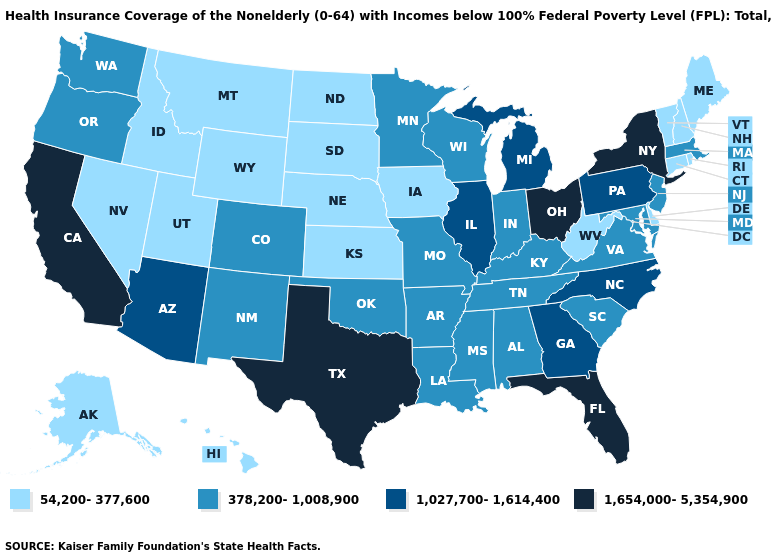Does the map have missing data?
Be succinct. No. What is the highest value in states that border Kentucky?
Concise answer only. 1,654,000-5,354,900. What is the value of West Virginia?
Write a very short answer. 54,200-377,600. Does Oklahoma have a higher value than Alaska?
Write a very short answer. Yes. Does Idaho have the lowest value in the USA?
Write a very short answer. Yes. What is the value of Kentucky?
Be succinct. 378,200-1,008,900. Name the states that have a value in the range 378,200-1,008,900?
Give a very brief answer. Alabama, Arkansas, Colorado, Indiana, Kentucky, Louisiana, Maryland, Massachusetts, Minnesota, Mississippi, Missouri, New Jersey, New Mexico, Oklahoma, Oregon, South Carolina, Tennessee, Virginia, Washington, Wisconsin. Name the states that have a value in the range 1,027,700-1,614,400?
Concise answer only. Arizona, Georgia, Illinois, Michigan, North Carolina, Pennsylvania. What is the value of Mississippi?
Concise answer only. 378,200-1,008,900. Does New Mexico have a higher value than Montana?
Give a very brief answer. Yes. Which states have the highest value in the USA?
Short answer required. California, Florida, New York, Ohio, Texas. What is the value of Hawaii?
Write a very short answer. 54,200-377,600. Among the states that border Montana , which have the highest value?
Write a very short answer. Idaho, North Dakota, South Dakota, Wyoming. Does Virginia have the highest value in the South?
Short answer required. No. 